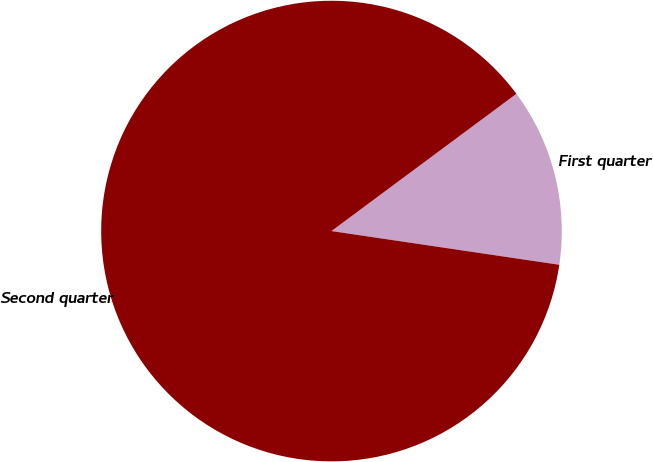Convert chart to OTSL. <chart><loc_0><loc_0><loc_500><loc_500><pie_chart><fcel>First quarter<fcel>Second quarter<nl><fcel>12.5%<fcel>87.5%<nl></chart> 